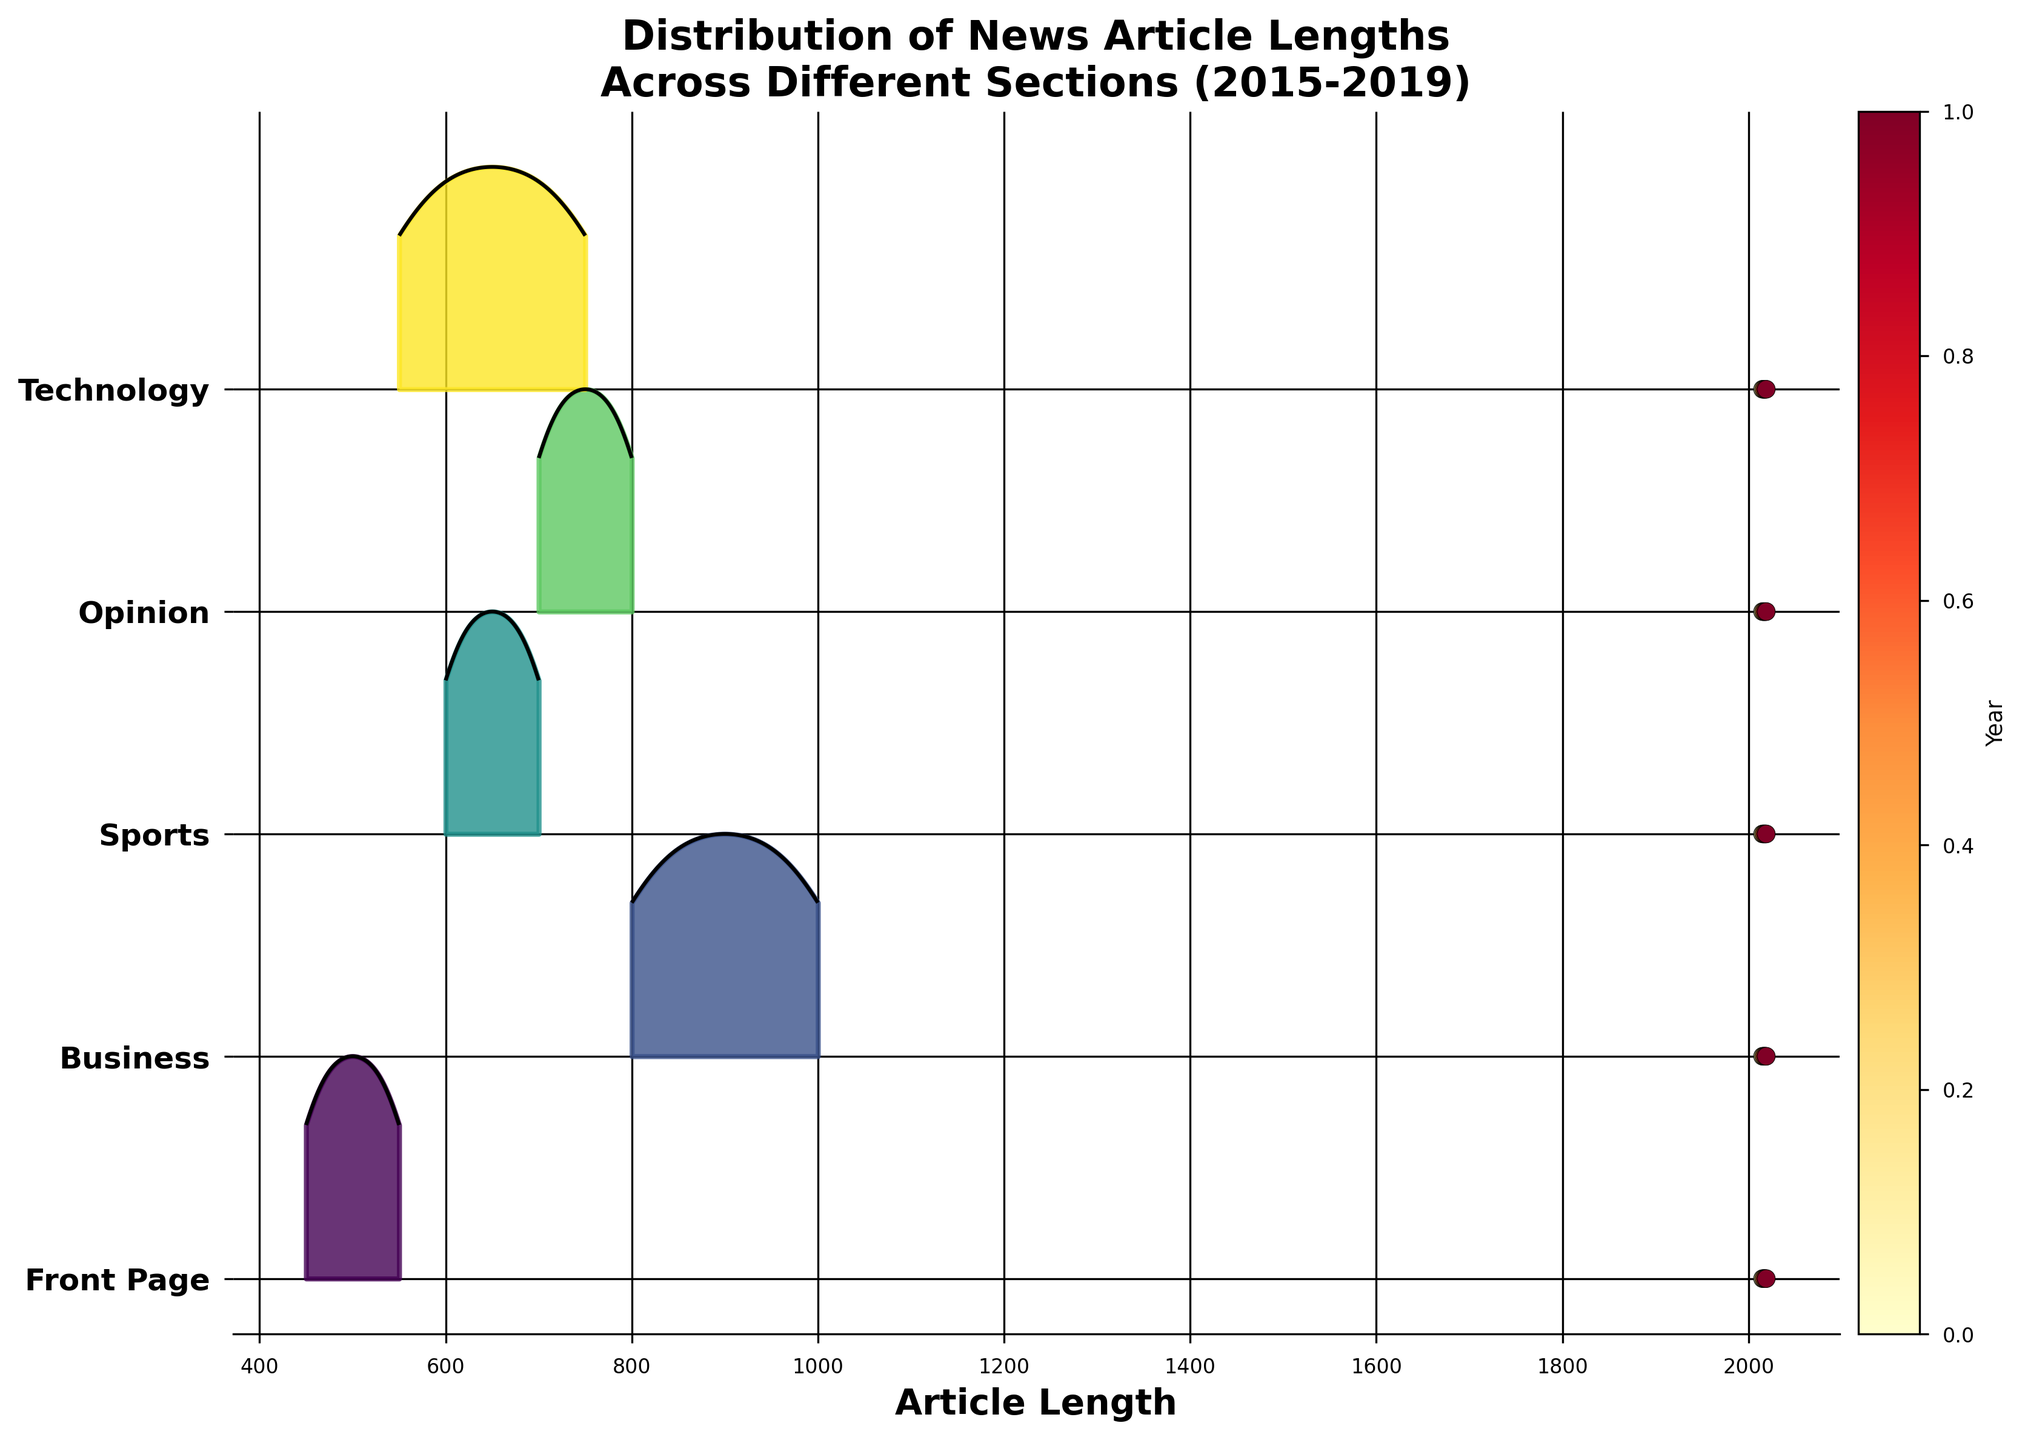what is the overall trend of article lengths in the Front Page section from 2015 to 2019? The plot shows the Front Page section's ridge increasing in length density from left to right across the years, ascending from 450 in 2015 to 550 by 2019, reflecting a general increasing trend in article length.
Answer: Increasing trend How do the article lengths in the Business section in 2019 compare to those in the Technology section? By observing the two ridgelines, the Business section's density curve is centered around 1000 in 2019, whereas the Technology section’s density curve is centered around 750. Thus, article lengths in the Business section are longer.
Answer: Business section articles are longer Which section has the most consistent article lengths over the years? The Opinion section’s ridgeline displays minimal variance in its density curve over the years. Thus, it exhibits the most consistent article lengths.
Answer: Opinion section What was the approximate article length midpoint for the Sports section in 2017? In the Ridgeline plot, the midpoint or peak distribution of the Sports section in 2017 falls roughly at 650.
Answer: 650 From 2015 to 2019, which section shows the highest density value? By observing the highest peaks, the Front Page section reaches the highest density values in its distribution curves over the years, standing taller than others.
Answer: Front Page section Which year does the Technology section have the shortest article length on average? Reviewing the Technology section's density curves, their shortest average length is at the earliest year, which appears to be around 2015 with an average length number of approximately 550.
Answer: 2015 How does the length distribution of articles in the Sports section in 2016 differ from the Business section in the same year? The density curve of the Sports section in 2016 peaks around 625, while in the Business section peaks around 850 for the same year. This indicates Sports articles are generally shorter in comparison.
Answer: Sports Articles are shorter Does any section show a decreasing trend in article length from 2015 to 2019? All Ridge curves in the plot show an increase or steady trend in lengths from left to right, indicating no section shows a decreasing trend.
Answer: No section shows a decreasing trend Among all sections, which one has the greatest variance in article lengths over the given years? The Business section's density curves show the greatest range of distribution spread among the displayed years, suggesting the highest variance in article lengths.
Answer: Business section Which section had the highest density curve in 2018? Checking the plot, the Front Page ridgeline density curve for 2018 is notably higher than other sections.
Answer: Front Page 